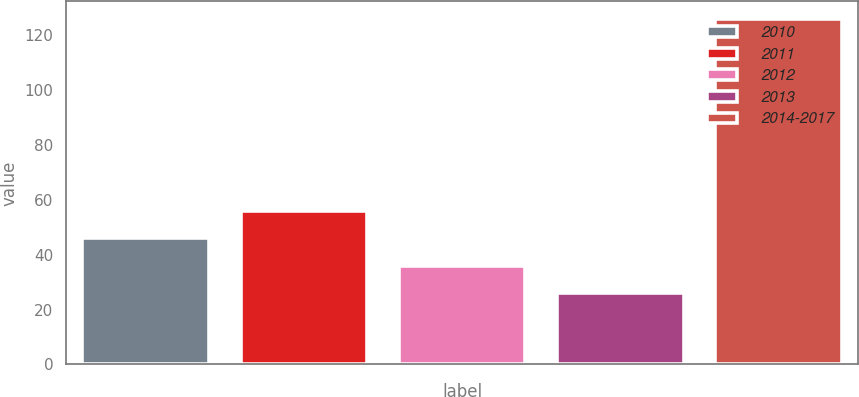<chart> <loc_0><loc_0><loc_500><loc_500><bar_chart><fcel>2010<fcel>2011<fcel>2012<fcel>2013<fcel>2014-2017<nl><fcel>46<fcel>56<fcel>36<fcel>26<fcel>126<nl></chart> 